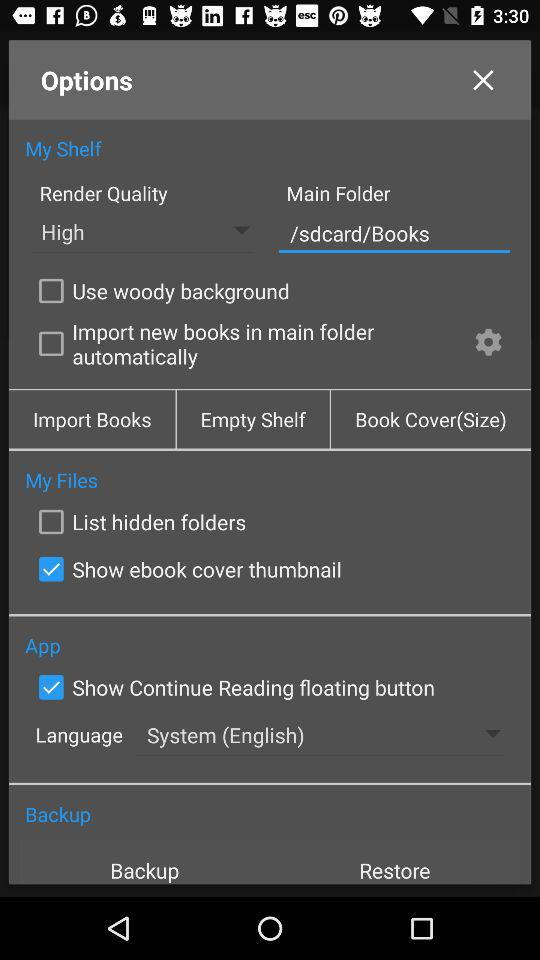Which option is selected? The options "Show ebook cover thumbnail" and "Show Continue Reading floating button" are selected. 